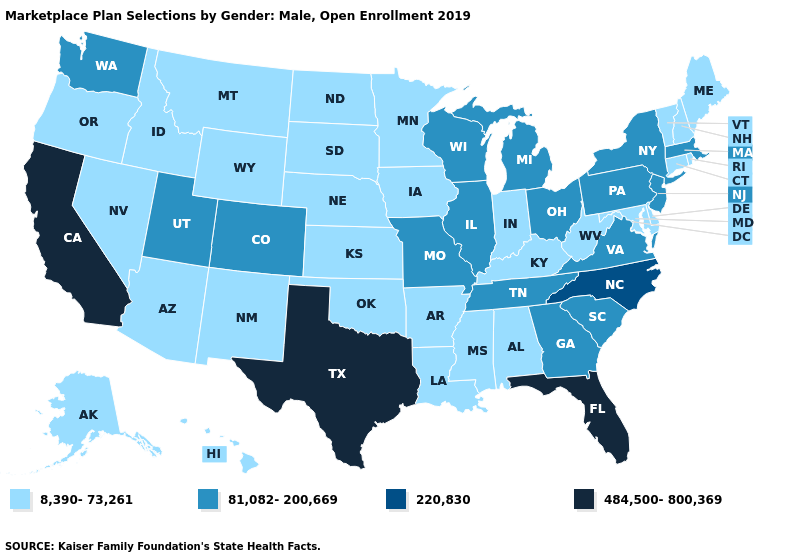What is the value of Maine?
Give a very brief answer. 8,390-73,261. What is the value of Utah?
Give a very brief answer. 81,082-200,669. What is the value of Colorado?
Keep it brief. 81,082-200,669. Among the states that border Nebraska , does Iowa have the highest value?
Write a very short answer. No. Name the states that have a value in the range 81,082-200,669?
Be succinct. Colorado, Georgia, Illinois, Massachusetts, Michigan, Missouri, New Jersey, New York, Ohio, Pennsylvania, South Carolina, Tennessee, Utah, Virginia, Washington, Wisconsin. Does Delaware have a higher value than Mississippi?
Keep it brief. No. Name the states that have a value in the range 484,500-800,369?
Write a very short answer. California, Florida, Texas. Does Ohio have the lowest value in the MidWest?
Keep it brief. No. What is the value of Virginia?
Answer briefly. 81,082-200,669. Which states have the lowest value in the MidWest?
Concise answer only. Indiana, Iowa, Kansas, Minnesota, Nebraska, North Dakota, South Dakota. Does Oklahoma have the highest value in the South?
Short answer required. No. Which states hav the highest value in the Northeast?
Quick response, please. Massachusetts, New Jersey, New York, Pennsylvania. Which states have the highest value in the USA?
Short answer required. California, Florida, Texas. 